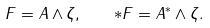Convert formula to latex. <formula><loc_0><loc_0><loc_500><loc_500>F = A \wedge \zeta , \quad * F = A ^ { * } \wedge \zeta .</formula> 